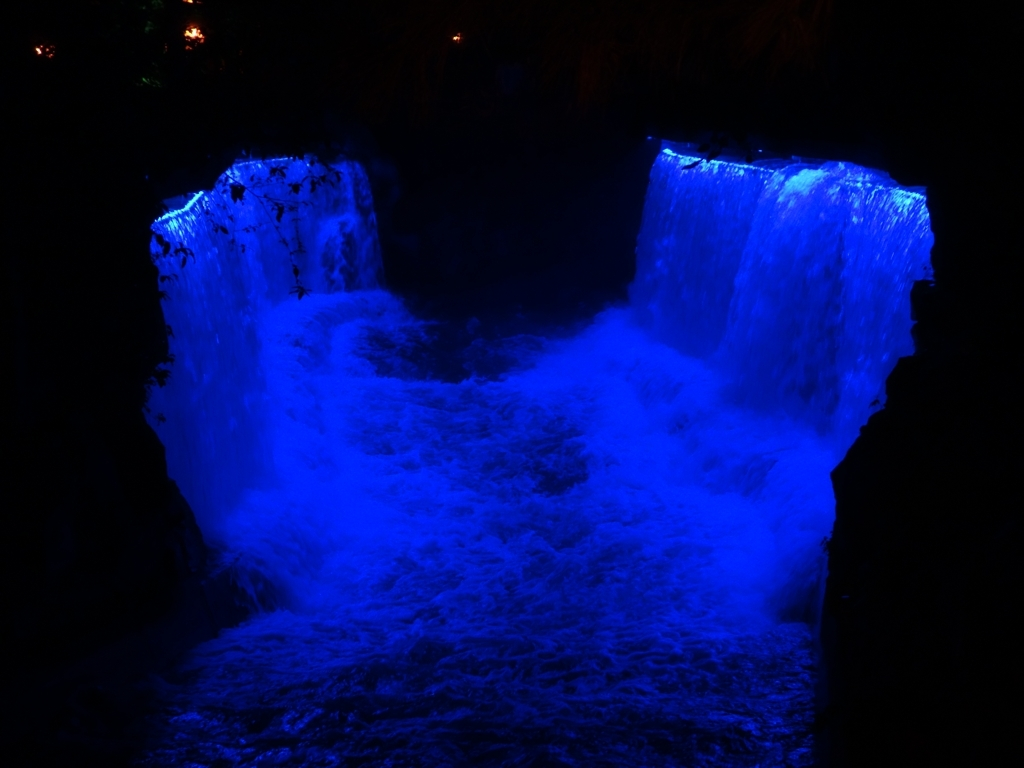What can be seen at the bottom of the waterfall?
A. Visible texture of water flow
B. Clear reflections of the sky
C. Smooth surface
D. Swimming fish While observing the bottom of the waterfall, the most prominent feature is the visible texture of the turbulent water flow, which is accentuated by the play of blue light on the splashing patterns. Option A is the most accurate: the dynamic texture created by the waterfall's churning is vividly apparent as the water crashes down. 